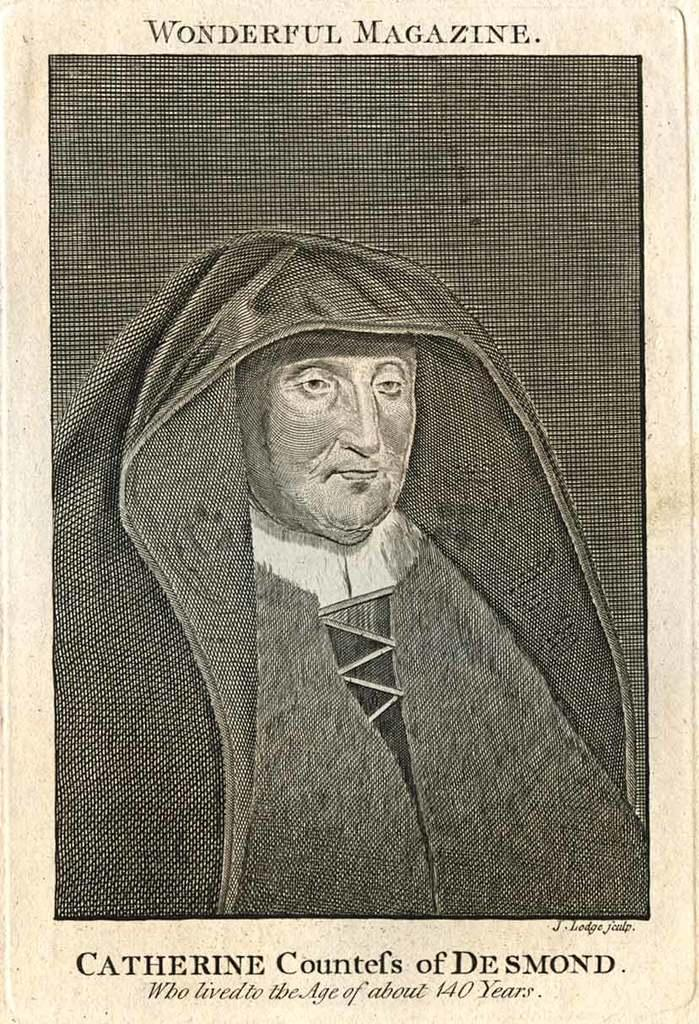What is present in the image that features a visual representation? There is a poster in the image. What can be seen in the picture on the poster? The poster contains a picture of a person. What additional information is provided on the poster? There is text written on the poster. What type of surprise can be seen on the grandmother's face in the image? There is no grandmother or surprise present in the image; it only features a poster with a picture of a person and text. 